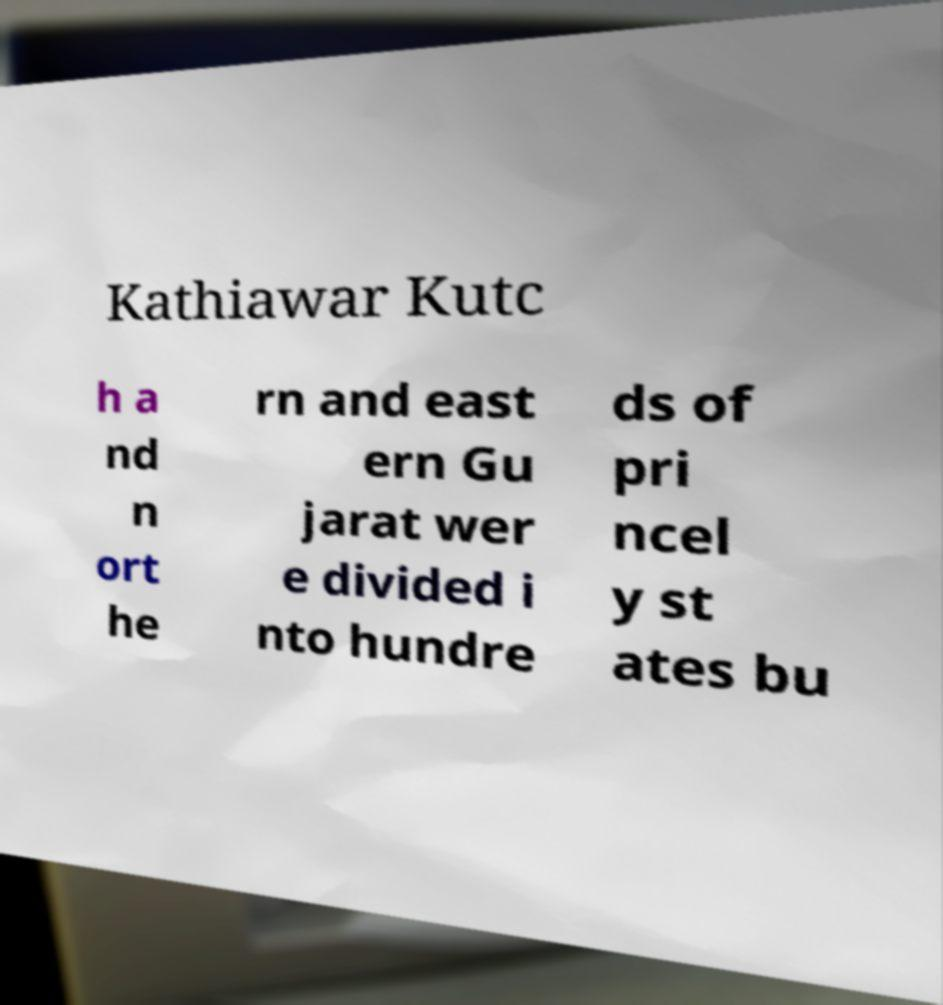Could you assist in decoding the text presented in this image and type it out clearly? Kathiawar Kutc h a nd n ort he rn and east ern Gu jarat wer e divided i nto hundre ds of pri ncel y st ates bu 